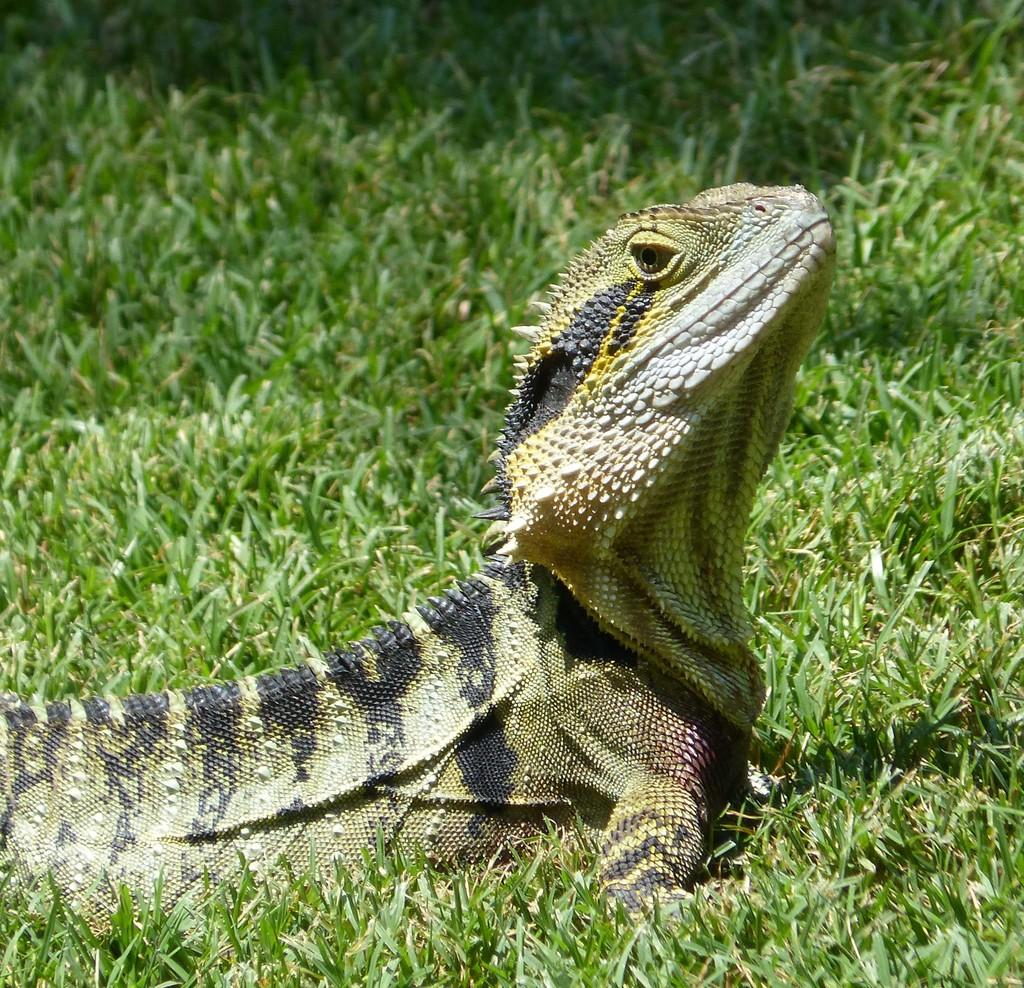What is the main subject of the image? There is a dragon lizard in the center of the image. What type of environment is visible in the background? There is grass visible in the background of the image. What type of cracker is being held by the secretary in the image? There is no secretary or cracker present in the image; it features a dragon lizard and grass in the background. 